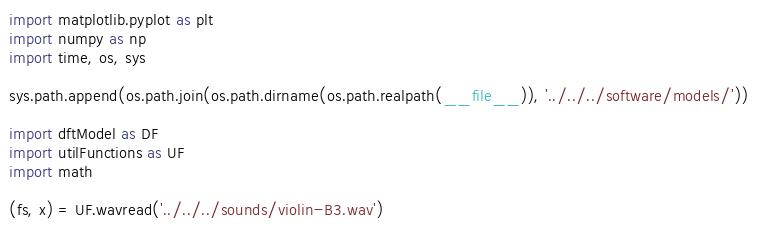Convert code to text. <code><loc_0><loc_0><loc_500><loc_500><_Python_>import matplotlib.pyplot as plt
import numpy as np
import time, os, sys

sys.path.append(os.path.join(os.path.dirname(os.path.realpath(__file__)), '../../../software/models/'))

import dftModel as DF
import utilFunctions as UF
import math

(fs, x) = UF.wavread('../../../sounds/violin-B3.wav')</code> 